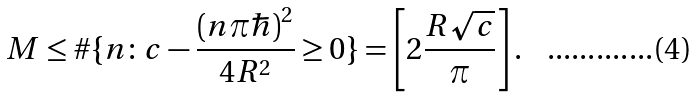<formula> <loc_0><loc_0><loc_500><loc_500>M \leq \# \{ n \colon c - \frac { ( n \pi \hbar { ) } ^ { 2 } } { 4 R ^ { 2 } } \geq 0 \} = \left [ 2 \frac { R \sqrt { c } } { \pi } \right ] .</formula> 